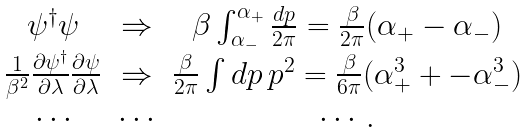<formula> <loc_0><loc_0><loc_500><loc_500>\begin{array} { c c c } { { \psi ^ { \dagger } \psi } } & { \Rightarrow } & { { \beta \int _ { \alpha _ { - } } ^ { \alpha _ { + } } { \frac { d p } { 2 \pi } } = { \frac { \beta } { 2 \pi } } ( \alpha _ { + } - \alpha _ { - } ) } } \\ { { { \frac { 1 } { \beta ^ { 2 } } } { \frac { \partial \psi ^ { \dagger } } { \partial \lambda } } { \frac { \partial \psi } { \partial \lambda } } } } & { \Rightarrow } & { { { \frac { \beta } { 2 \pi } } \int d p \, p ^ { 2 } = { \frac { \beta } { 6 \pi } } ( \alpha _ { + } ^ { 3 } + - \alpha _ { - } ^ { 3 } ) } } \\ { \cdots } & { \cdots } & { \cdots . } \end{array}</formula> 